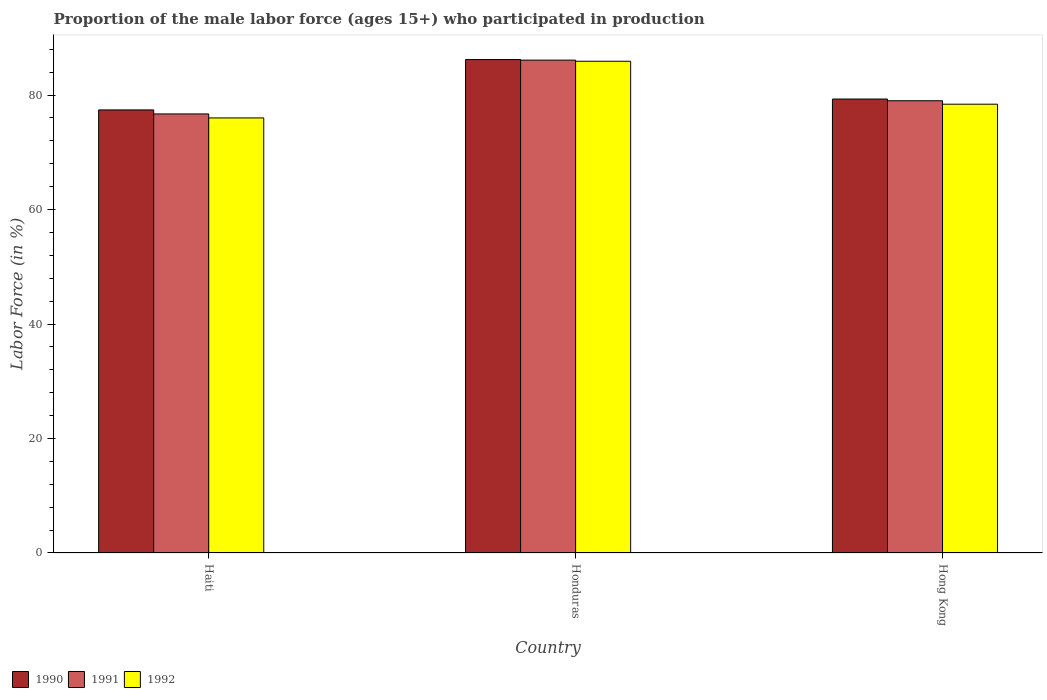How many different coloured bars are there?
Offer a very short reply. 3. How many groups of bars are there?
Make the answer very short. 3. Are the number of bars per tick equal to the number of legend labels?
Give a very brief answer. Yes. Are the number of bars on each tick of the X-axis equal?
Your answer should be very brief. Yes. What is the label of the 3rd group of bars from the left?
Keep it short and to the point. Hong Kong. What is the proportion of the male labor force who participated in production in 1991 in Hong Kong?
Offer a very short reply. 79. Across all countries, what is the maximum proportion of the male labor force who participated in production in 1992?
Your answer should be compact. 85.9. Across all countries, what is the minimum proportion of the male labor force who participated in production in 1990?
Your response must be concise. 77.4. In which country was the proportion of the male labor force who participated in production in 1992 maximum?
Your response must be concise. Honduras. In which country was the proportion of the male labor force who participated in production in 1991 minimum?
Provide a succinct answer. Haiti. What is the total proportion of the male labor force who participated in production in 1992 in the graph?
Your answer should be very brief. 240.3. What is the difference between the proportion of the male labor force who participated in production in 1990 in Haiti and that in Honduras?
Offer a very short reply. -8.8. What is the difference between the proportion of the male labor force who participated in production in 1991 in Haiti and the proportion of the male labor force who participated in production in 1992 in Hong Kong?
Make the answer very short. -1.7. What is the average proportion of the male labor force who participated in production in 1990 per country?
Provide a succinct answer. 80.97. What is the difference between the proportion of the male labor force who participated in production of/in 1992 and proportion of the male labor force who participated in production of/in 1991 in Hong Kong?
Your answer should be compact. -0.6. In how many countries, is the proportion of the male labor force who participated in production in 1991 greater than 76 %?
Keep it short and to the point. 3. What is the ratio of the proportion of the male labor force who participated in production in 1992 in Haiti to that in Honduras?
Your answer should be very brief. 0.88. Is the difference between the proportion of the male labor force who participated in production in 1992 in Haiti and Honduras greater than the difference between the proportion of the male labor force who participated in production in 1991 in Haiti and Honduras?
Your response must be concise. No. What is the difference between the highest and the second highest proportion of the male labor force who participated in production in 1991?
Your response must be concise. -9.4. What is the difference between the highest and the lowest proportion of the male labor force who participated in production in 1992?
Make the answer very short. 9.9. Is the sum of the proportion of the male labor force who participated in production in 1990 in Honduras and Hong Kong greater than the maximum proportion of the male labor force who participated in production in 1991 across all countries?
Your response must be concise. Yes. What does the 3rd bar from the left in Honduras represents?
Provide a short and direct response. 1992. What does the 3rd bar from the right in Hong Kong represents?
Offer a very short reply. 1990. Is it the case that in every country, the sum of the proportion of the male labor force who participated in production in 1992 and proportion of the male labor force who participated in production in 1991 is greater than the proportion of the male labor force who participated in production in 1990?
Keep it short and to the point. Yes. Are all the bars in the graph horizontal?
Your response must be concise. No. What is the difference between two consecutive major ticks on the Y-axis?
Your answer should be very brief. 20. Are the values on the major ticks of Y-axis written in scientific E-notation?
Keep it short and to the point. No. Does the graph contain any zero values?
Provide a succinct answer. No. Where does the legend appear in the graph?
Your answer should be compact. Bottom left. What is the title of the graph?
Your answer should be very brief. Proportion of the male labor force (ages 15+) who participated in production. What is the label or title of the Y-axis?
Offer a terse response. Labor Force (in %). What is the Labor Force (in %) of 1990 in Haiti?
Your response must be concise. 77.4. What is the Labor Force (in %) of 1991 in Haiti?
Offer a terse response. 76.7. What is the Labor Force (in %) in 1990 in Honduras?
Provide a succinct answer. 86.2. What is the Labor Force (in %) in 1991 in Honduras?
Give a very brief answer. 86.1. What is the Labor Force (in %) in 1992 in Honduras?
Your response must be concise. 85.9. What is the Labor Force (in %) in 1990 in Hong Kong?
Offer a terse response. 79.3. What is the Labor Force (in %) in 1991 in Hong Kong?
Offer a terse response. 79. What is the Labor Force (in %) of 1992 in Hong Kong?
Keep it short and to the point. 78.4. Across all countries, what is the maximum Labor Force (in %) of 1990?
Make the answer very short. 86.2. Across all countries, what is the maximum Labor Force (in %) in 1991?
Offer a very short reply. 86.1. Across all countries, what is the maximum Labor Force (in %) of 1992?
Make the answer very short. 85.9. Across all countries, what is the minimum Labor Force (in %) of 1990?
Keep it short and to the point. 77.4. Across all countries, what is the minimum Labor Force (in %) in 1991?
Offer a very short reply. 76.7. Across all countries, what is the minimum Labor Force (in %) in 1992?
Keep it short and to the point. 76. What is the total Labor Force (in %) of 1990 in the graph?
Give a very brief answer. 242.9. What is the total Labor Force (in %) in 1991 in the graph?
Your answer should be compact. 241.8. What is the total Labor Force (in %) in 1992 in the graph?
Offer a terse response. 240.3. What is the difference between the Labor Force (in %) in 1992 in Haiti and that in Honduras?
Ensure brevity in your answer.  -9.9. What is the difference between the Labor Force (in %) of 1990 in Haiti and that in Hong Kong?
Provide a succinct answer. -1.9. What is the difference between the Labor Force (in %) of 1991 in Haiti and that in Hong Kong?
Your answer should be very brief. -2.3. What is the difference between the Labor Force (in %) in 1990 in Haiti and the Labor Force (in %) in 1991 in Honduras?
Offer a very short reply. -8.7. What is the difference between the Labor Force (in %) in 1991 in Haiti and the Labor Force (in %) in 1992 in Honduras?
Your answer should be compact. -9.2. What is the difference between the Labor Force (in %) of 1990 in Haiti and the Labor Force (in %) of 1991 in Hong Kong?
Give a very brief answer. -1.6. What is the difference between the Labor Force (in %) in 1990 in Haiti and the Labor Force (in %) in 1992 in Hong Kong?
Your answer should be compact. -1. What is the difference between the Labor Force (in %) of 1991 in Haiti and the Labor Force (in %) of 1992 in Hong Kong?
Your response must be concise. -1.7. What is the difference between the Labor Force (in %) in 1991 in Honduras and the Labor Force (in %) in 1992 in Hong Kong?
Your answer should be very brief. 7.7. What is the average Labor Force (in %) in 1990 per country?
Your answer should be very brief. 80.97. What is the average Labor Force (in %) in 1991 per country?
Keep it short and to the point. 80.6. What is the average Labor Force (in %) in 1992 per country?
Your answer should be very brief. 80.1. What is the difference between the Labor Force (in %) in 1990 and Labor Force (in %) in 1992 in Honduras?
Your response must be concise. 0.3. What is the difference between the Labor Force (in %) in 1991 and Labor Force (in %) in 1992 in Honduras?
Provide a short and direct response. 0.2. What is the difference between the Labor Force (in %) of 1990 and Labor Force (in %) of 1991 in Hong Kong?
Ensure brevity in your answer.  0.3. What is the difference between the Labor Force (in %) in 1991 and Labor Force (in %) in 1992 in Hong Kong?
Your response must be concise. 0.6. What is the ratio of the Labor Force (in %) of 1990 in Haiti to that in Honduras?
Make the answer very short. 0.9. What is the ratio of the Labor Force (in %) of 1991 in Haiti to that in Honduras?
Make the answer very short. 0.89. What is the ratio of the Labor Force (in %) in 1992 in Haiti to that in Honduras?
Keep it short and to the point. 0.88. What is the ratio of the Labor Force (in %) in 1991 in Haiti to that in Hong Kong?
Make the answer very short. 0.97. What is the ratio of the Labor Force (in %) in 1992 in Haiti to that in Hong Kong?
Give a very brief answer. 0.97. What is the ratio of the Labor Force (in %) in 1990 in Honduras to that in Hong Kong?
Keep it short and to the point. 1.09. What is the ratio of the Labor Force (in %) of 1991 in Honduras to that in Hong Kong?
Offer a very short reply. 1.09. What is the ratio of the Labor Force (in %) of 1992 in Honduras to that in Hong Kong?
Give a very brief answer. 1.1. What is the difference between the highest and the second highest Labor Force (in %) in 1990?
Your answer should be very brief. 6.9. What is the difference between the highest and the second highest Labor Force (in %) in 1991?
Give a very brief answer. 7.1. What is the difference between the highest and the lowest Labor Force (in %) of 1990?
Your response must be concise. 8.8. 